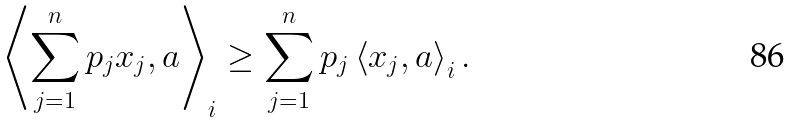<formula> <loc_0><loc_0><loc_500><loc_500>\left \langle \sum _ { j = 1 } ^ { n } p _ { j } x _ { j } , a \right \rangle _ { i } \geq \sum _ { j = 1 } ^ { n } p _ { j } \left \langle x _ { j } , a \right \rangle _ { i } .</formula> 